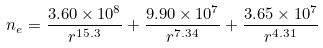<formula> <loc_0><loc_0><loc_500><loc_500>n _ { e } = \frac { 3 . 6 0 \times 1 0 ^ { 8 } } { r ^ { 1 5 . 3 } } + \frac { 9 . 9 0 \times 1 0 ^ { 7 } } { r ^ { 7 . 3 4 } } + \frac { 3 . 6 5 \times 1 0 ^ { 7 } } { r ^ { 4 . 3 1 } }</formula> 